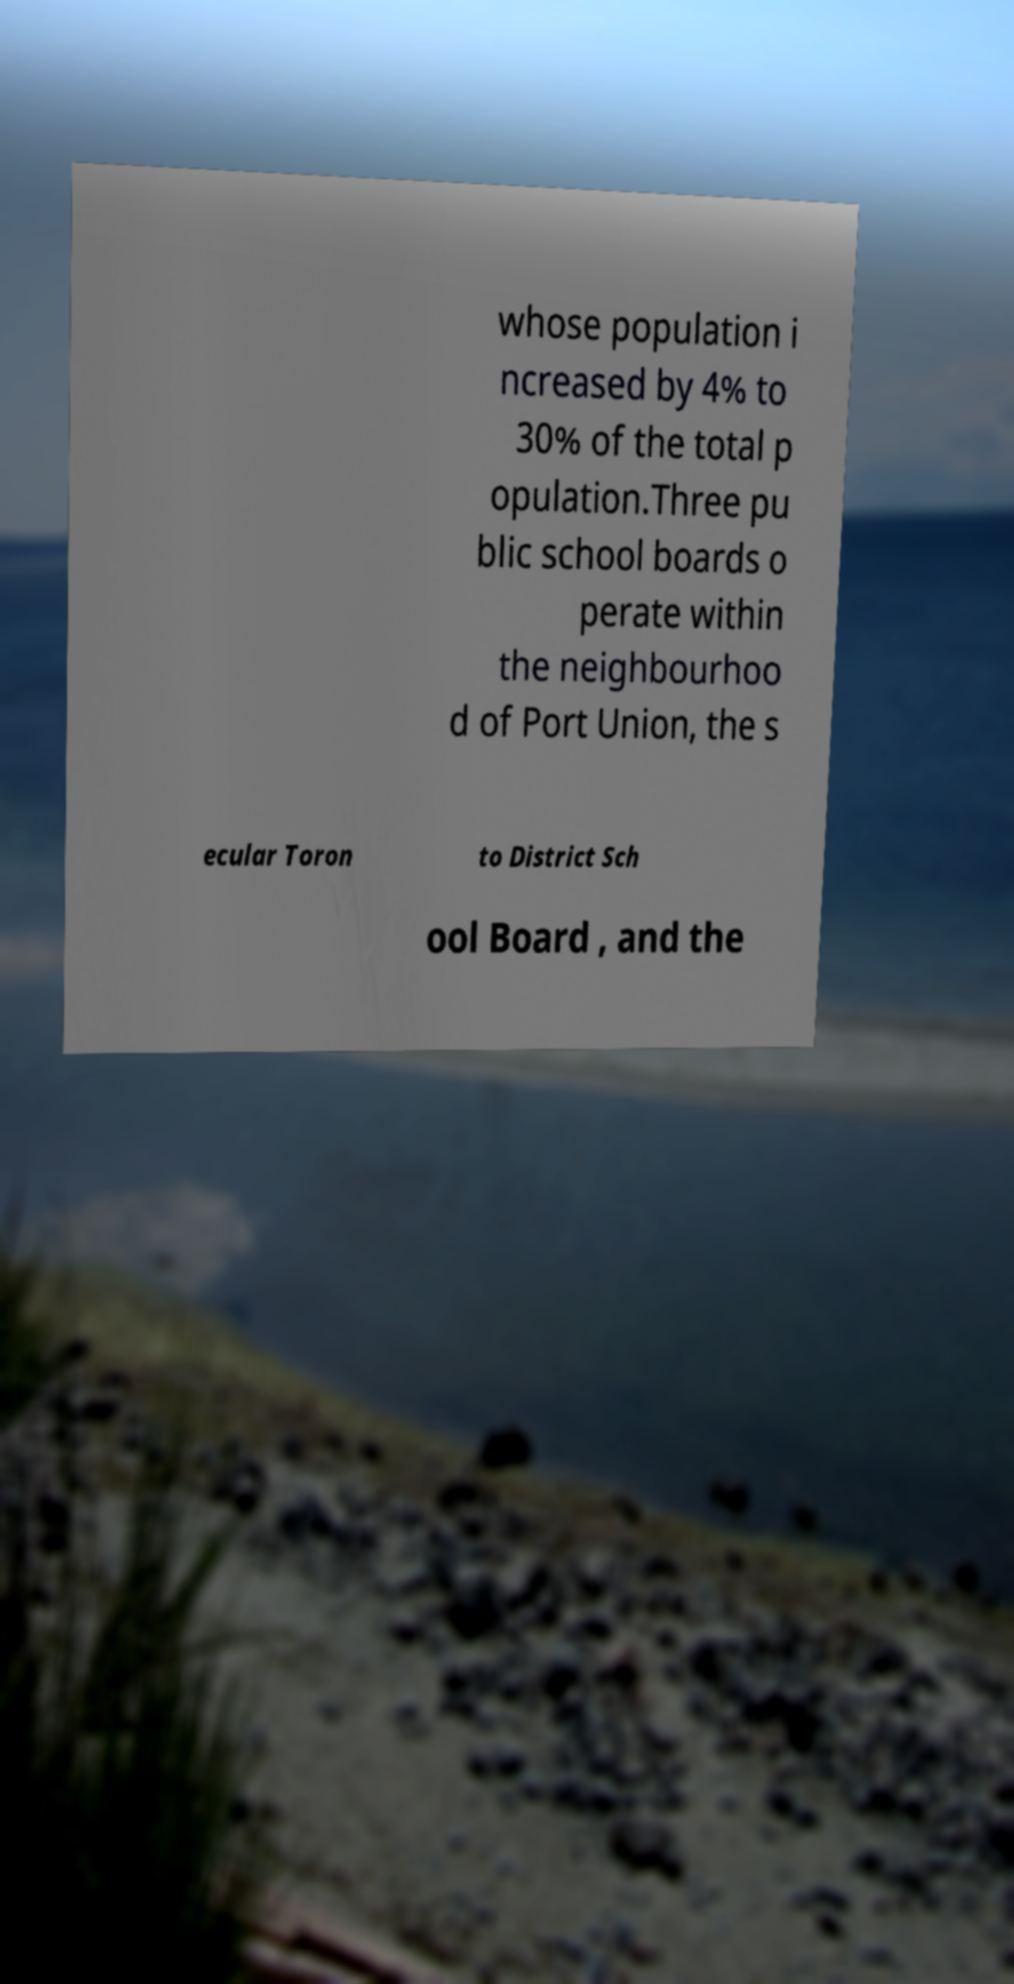I need the written content from this picture converted into text. Can you do that? whose population i ncreased by 4% to 30% of the total p opulation.Three pu blic school boards o perate within the neighbourhoo d of Port Union, the s ecular Toron to District Sch ool Board , and the 